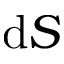Convert formula to latex. <formula><loc_0><loc_0><loc_500><loc_500>d S</formula> 